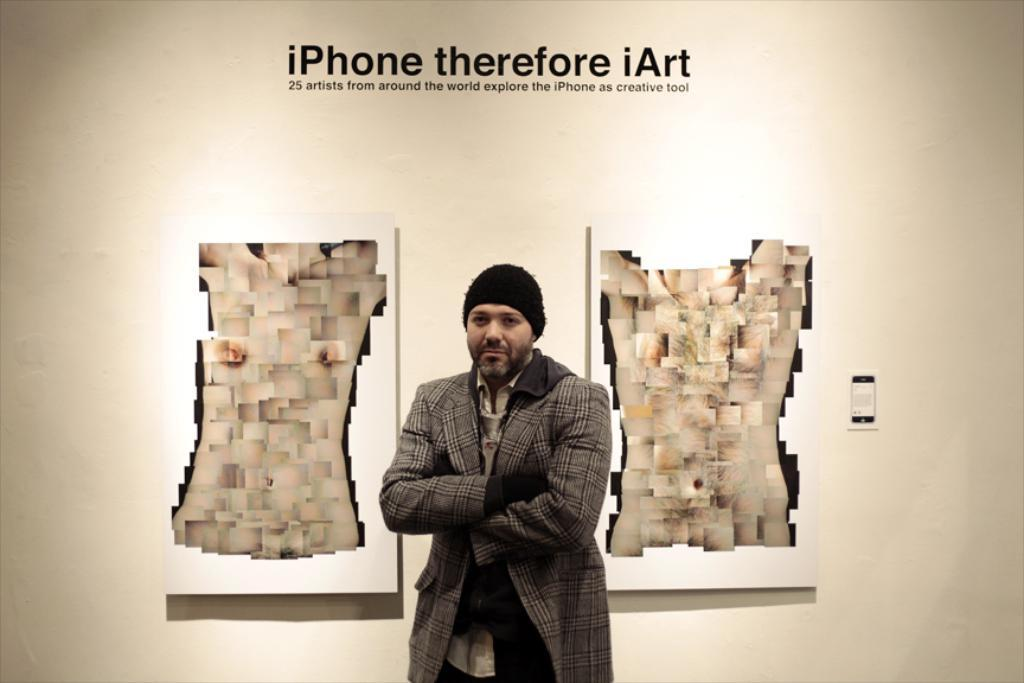Who is present in the image? There is a man in the picture. What is the man doing in the image? The man is standing near a wall and folding his hands. What is the man wearing in the image? The man is wearing a blazer and a black color cap. What can be seen on the wall in the image? There is an advertisement of the iPhone on the wall. What type of attraction can be seen in the box in the image? There is no box or attraction present in the image. 